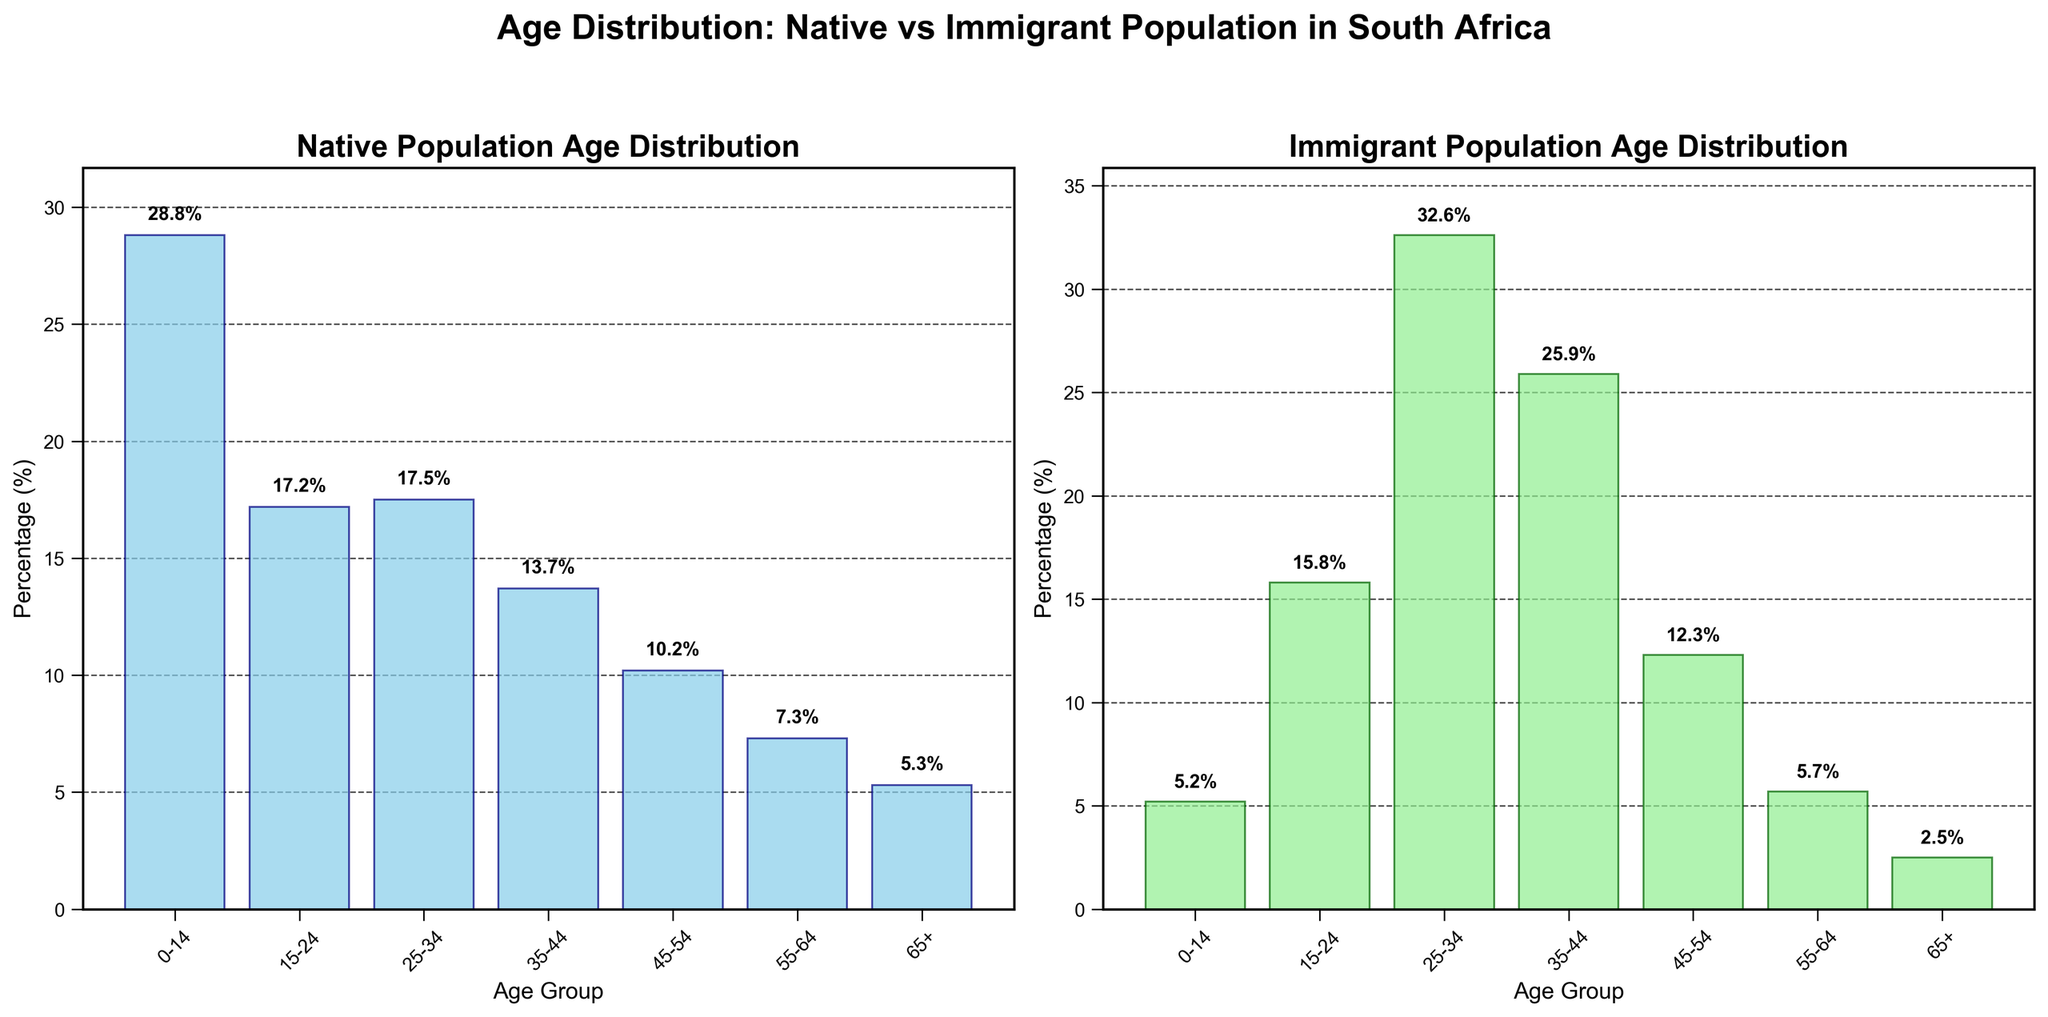What is the age group with the highest percentage in the native population? Look at the 'Native Population Age Distribution' plot and find the tallest bar, which represents the age group 0-14 with 28.8%.
Answer: 0-14 What is the percentage of immigrants in the age group 25-34? Refer to the 'Immigrant Population Age Distribution' plot and locate the bar for the age group 25-34, which shows a percentage of 32.6%.
Answer: 32.6% Which age group has the lowest percentage among immigrants? In the 'Immigrant Population Age Distribution' plot, identify the shortest bar, which represents the age group 65+ with 2.5%.
Answer: 65+ By how much does the percentage of immigrants in the age group 25-34 exceed that of the native population? Subtract the percentage of the native population in the age group 25-34 (17.5%) from the percentage of immigrants in the same age group (32.6%), resulting in 32.6% - 17.5% = 15.1%.
Answer: 15.1% Compare the percentages of the age group 35-44 in both populations. Which one is higher and by how much? Find the percentage for age group 35-44 in both plots: Native (13.7%) and Immigrant (25.9%). The immigrant percentage is higher. Calculate the difference: 25.9% - 13.7% = 12.2%.
Answer: Immigrant by 12.2% What is the combined percentage of immigrants in the age groups 0-14 and 65+? Add the percentages of immigrants for the age groups 0-14 (5.2%) and 65+ (2.5%): 5.2% + 2.5% = 7.7%.
Answer: 7.7% Which age group has a higher percentage in the native population compared to immigrants, and by what value? Compare each age group's percentage between the native and immigrant populations. The age group 0-14 in the native population (28.8%) is higher than that in the immigrant population (5.2%). Calculate the difference: 28.8% - 5.2% = 23.6%.
Answer: 0-14 by 23.6% What is the overall trend in age distribution for immigrants compared to the native population? Observe the general shape and distribution of the bars in both plots: Immigrant distribution peaks at 25-34 and declines significantly after 44, whereas the native population has a more evenly spread distribution across younger age groups.
Answer: Higher concentration in 25-44 ages for immigrants, more spread in younger ages for natives 